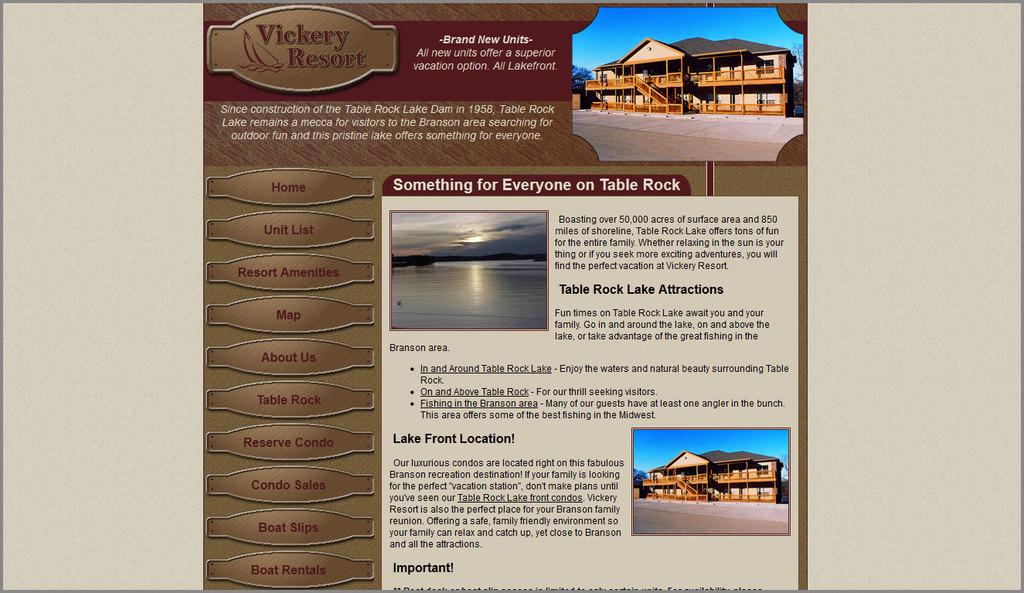<image>
Create a compact narrative representing the image presented. An information docket for the Vickery Resort with information and illustration. 